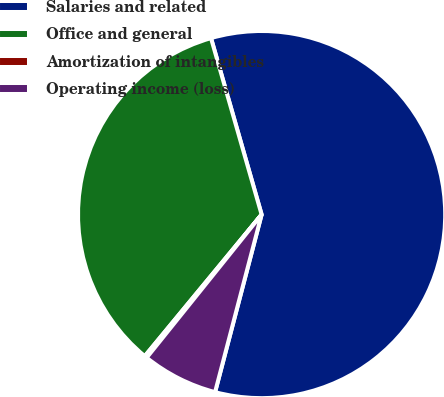<chart> <loc_0><loc_0><loc_500><loc_500><pie_chart><fcel>Salaries and related<fcel>Office and general<fcel>Amortization of intangibles<fcel>Operating income (loss)<nl><fcel>58.52%<fcel>34.57%<fcel>0.21%<fcel>6.69%<nl></chart> 